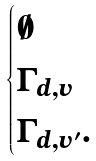Convert formula to latex. <formula><loc_0><loc_0><loc_500><loc_500>\begin{cases} \emptyset \\ \Gamma _ { d , v } \\ \Gamma _ { d , v ^ { \prime } } . \end{cases}</formula> 